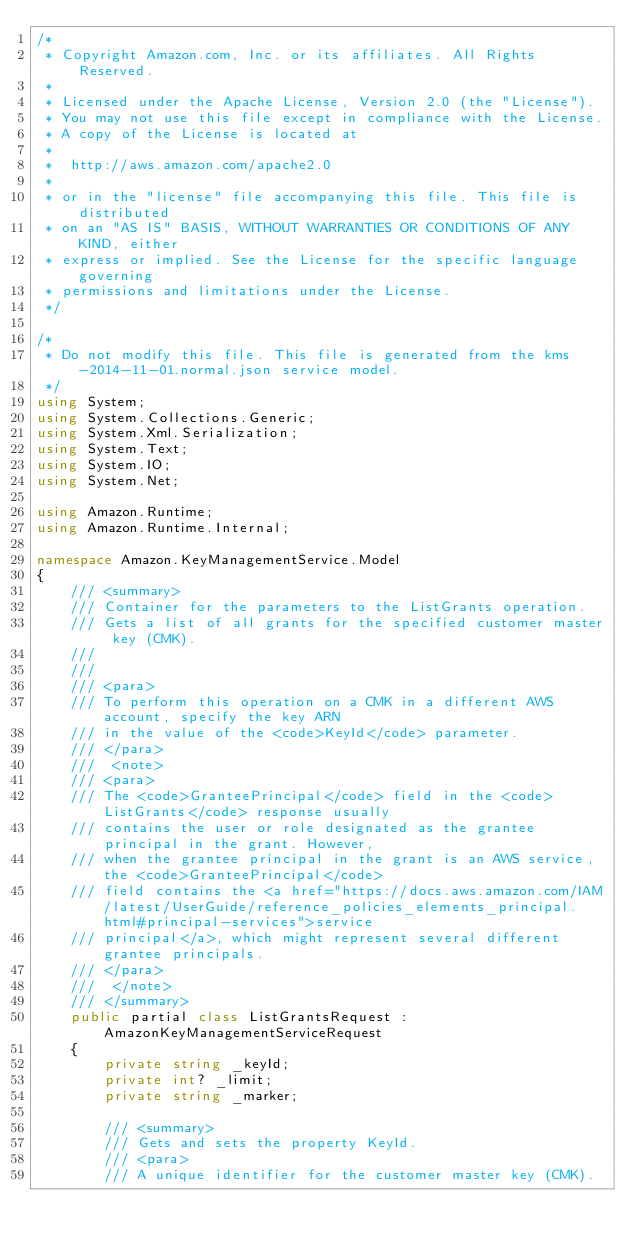<code> <loc_0><loc_0><loc_500><loc_500><_C#_>/*
 * Copyright Amazon.com, Inc. or its affiliates. All Rights Reserved.
 * 
 * Licensed under the Apache License, Version 2.0 (the "License").
 * You may not use this file except in compliance with the License.
 * A copy of the License is located at
 * 
 *  http://aws.amazon.com/apache2.0
 * 
 * or in the "license" file accompanying this file. This file is distributed
 * on an "AS IS" BASIS, WITHOUT WARRANTIES OR CONDITIONS OF ANY KIND, either
 * express or implied. See the License for the specific language governing
 * permissions and limitations under the License.
 */

/*
 * Do not modify this file. This file is generated from the kms-2014-11-01.normal.json service model.
 */
using System;
using System.Collections.Generic;
using System.Xml.Serialization;
using System.Text;
using System.IO;
using System.Net;

using Amazon.Runtime;
using Amazon.Runtime.Internal;

namespace Amazon.KeyManagementService.Model
{
    /// <summary>
    /// Container for the parameters to the ListGrants operation.
    /// Gets a list of all grants for the specified customer master key (CMK).
    /// 
    ///  
    /// <para>
    /// To perform this operation on a CMK in a different AWS account, specify the key ARN
    /// in the value of the <code>KeyId</code> parameter.
    /// </para>
    ///  <note> 
    /// <para>
    /// The <code>GranteePrincipal</code> field in the <code>ListGrants</code> response usually
    /// contains the user or role designated as the grantee principal in the grant. However,
    /// when the grantee principal in the grant is an AWS service, the <code>GranteePrincipal</code>
    /// field contains the <a href="https://docs.aws.amazon.com/IAM/latest/UserGuide/reference_policies_elements_principal.html#principal-services">service
    /// principal</a>, which might represent several different grantee principals.
    /// </para>
    ///  </note>
    /// </summary>
    public partial class ListGrantsRequest : AmazonKeyManagementServiceRequest
    {
        private string _keyId;
        private int? _limit;
        private string _marker;

        /// <summary>
        /// Gets and sets the property KeyId. 
        /// <para>
        /// A unique identifier for the customer master key (CMK).</code> 